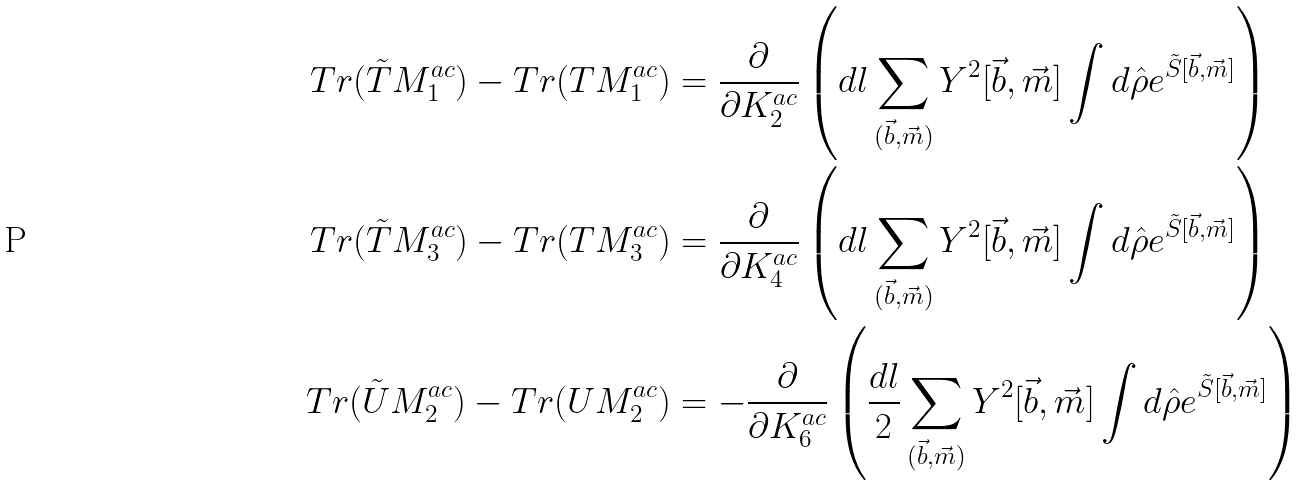Convert formula to latex. <formula><loc_0><loc_0><loc_500><loc_500>T r ( \tilde { T } M _ { 1 } ^ { a c } ) - T r ( T M _ { 1 } ^ { a c } ) & = \frac { \partial } { \partial K _ { 2 } ^ { a c } } \left ( d l \sum _ { ( \vec { b } , \vec { m } ) } Y ^ { 2 } [ \vec { b } , \vec { m } ] \int d \hat { \rho } e ^ { \tilde { S } [ \vec { b } , \vec { m } ] } \right ) \\ T r ( \tilde { T } M _ { 3 } ^ { a c } ) - T r ( T M _ { 3 } ^ { a c } ) & = \frac { \partial } { \partial K _ { 4 } ^ { a c } } \left ( d l \sum _ { ( \vec { b } , \vec { m } ) } Y ^ { 2 } [ \vec { b } , \vec { m } ] \int d \hat { \rho } e ^ { \tilde { S } [ \vec { b } , \vec { m } ] } \right ) \\ T r ( \tilde { U } M _ { 2 } ^ { a c } ) - T r ( U M _ { 2 } ^ { a c } ) & = - \frac { \partial } { \partial K _ { 6 } ^ { a c } } \left ( \frac { d l } { 2 } \sum _ { ( \vec { b } , \vec { m } ) } Y ^ { 2 } [ \vec { b } , \vec { m } ] \int d \hat { \rho } e ^ { \tilde { S } [ \vec { b } , \vec { m } ] } \right )</formula> 